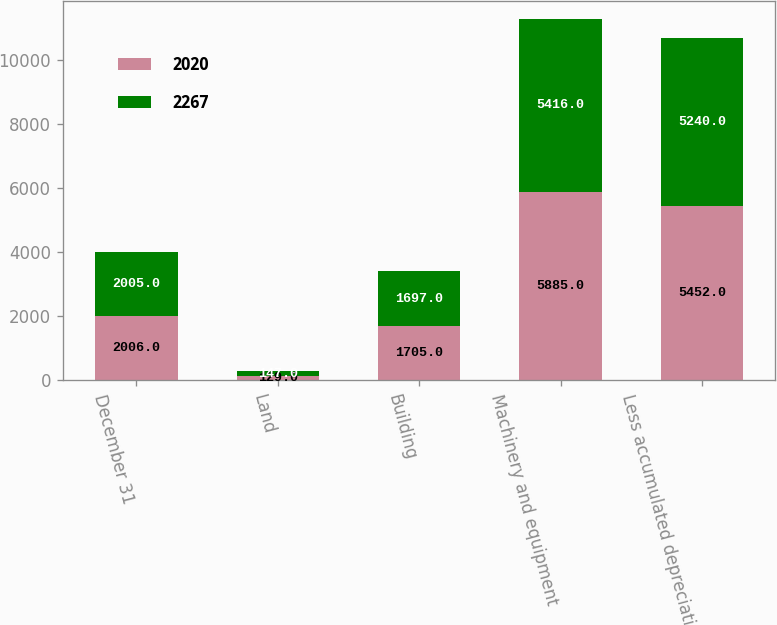Convert chart. <chart><loc_0><loc_0><loc_500><loc_500><stacked_bar_chart><ecel><fcel>December 31<fcel>Land<fcel>Building<fcel>Machinery and equipment<fcel>Less accumulated depreciation<nl><fcel>2020<fcel>2006<fcel>129<fcel>1705<fcel>5885<fcel>5452<nl><fcel>2267<fcel>2005<fcel>147<fcel>1697<fcel>5416<fcel>5240<nl></chart> 